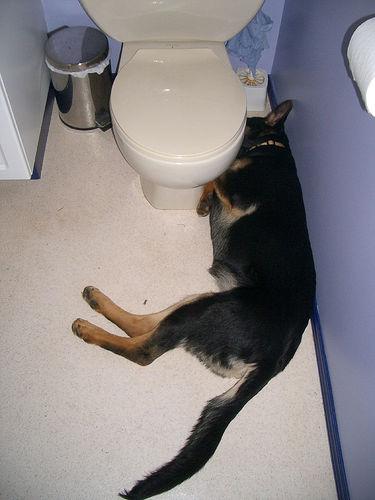What is on the right side of the toilet?
Give a very brief answer. Dog. What side of the toilet is the dog laying down at?
Quick response, please. Right. Why would most people find this image distasteful?
Answer briefly. No. What color is the floor?
Answer briefly. White. 